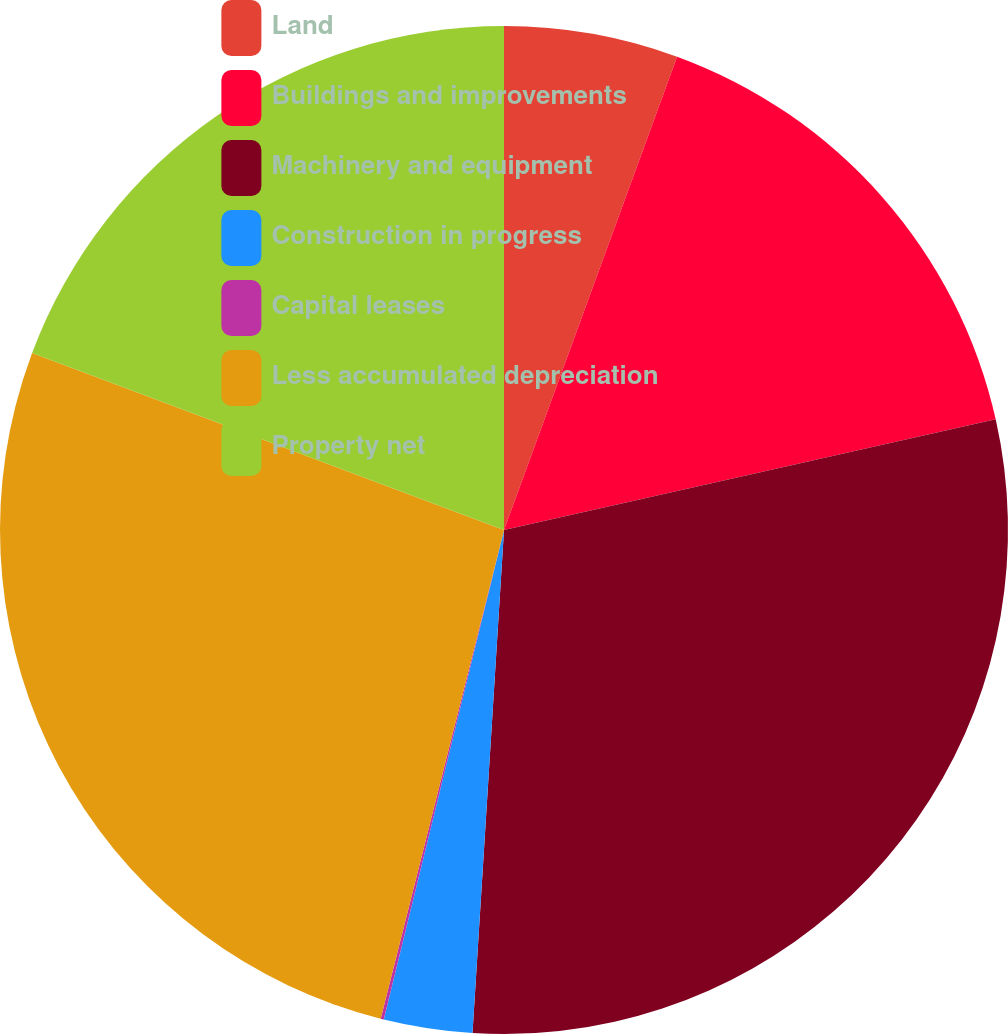<chart> <loc_0><loc_0><loc_500><loc_500><pie_chart><fcel>Land<fcel>Buildings and improvements<fcel>Machinery and equipment<fcel>Construction in progress<fcel>Capital leases<fcel>Less accumulated depreciation<fcel>Property net<nl><fcel>5.58%<fcel>15.9%<fcel>29.52%<fcel>2.84%<fcel>0.1%<fcel>26.78%<fcel>19.29%<nl></chart> 